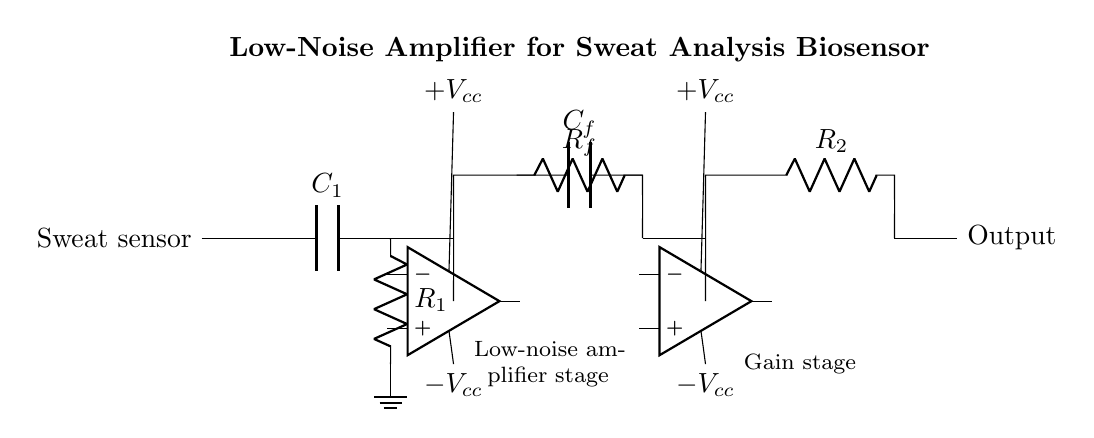What type of capacitor is used in the feedback loop? The circuit diagram shows a capacitor labeled C_f connected in the feedback loop of the first operational amplifier stage. This indicates that a feedback capacitor is used for stabilization or frequency response adjustment.
Answer: feedback capacitor What is the function of the resistor labeled R_f? The resistor R_f is part of the feedback network connected to the first operational amplifier stage and is used to set the gain of that amplifier, determining the amplification factor of the input signal.
Answer: gain setting How many operational amplifiers are present in the circuit? The circuit diagram clearly includes two operational amplifiers shown, each labeled, which are used to amplify the input from the sweat sensor.
Answer: two What is the purpose of the capacitor labeled C_1? The capacitor C_1 is used at the input stage to filter out high-frequency noise and stabilize the input signal from the sweat sensor, ensuring accurate sensor measurements.
Answer: input filtering What is the voltage supply configuration for this amplifier circuit? The operational amplifiers are both powered by dual supply voltages indicated as positive and negative V_cc at the top and bottom of the op-amp symbols, which is typical for bipolar operational amplifiers.
Answer: dual supply What role do resistors R_1 and R_2 play in this circuit? Resistors R_1 and R_2 are placed in the circuit to provide biasing and help set the gain for the corresponding amplifier stages, crucial for optimizing the performance of the signal amplification.
Answer: gain configuration 